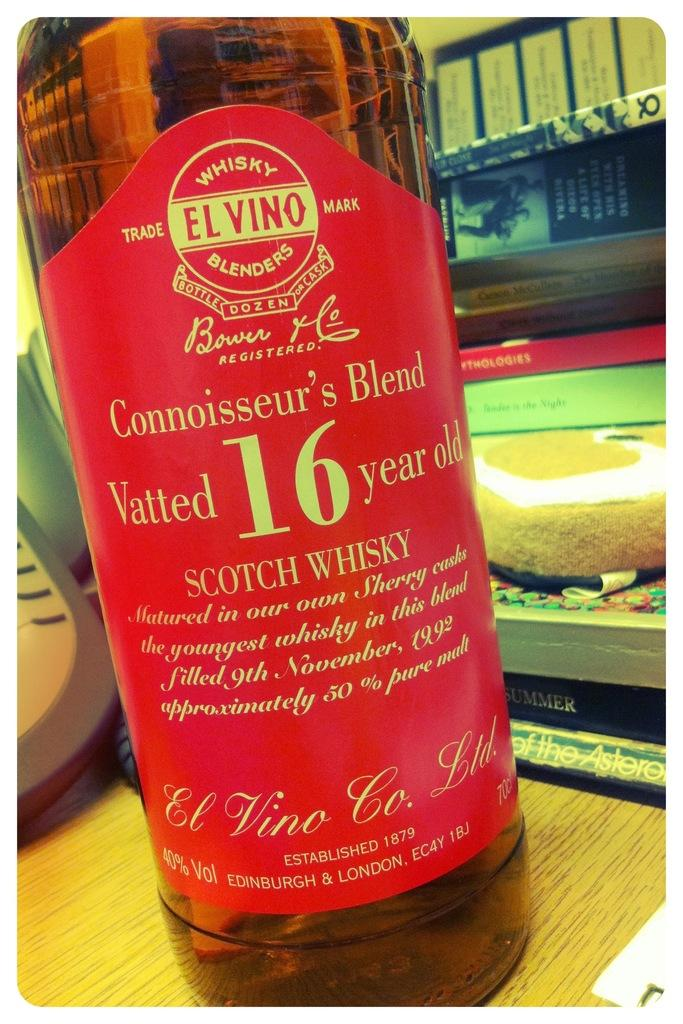<image>
Share a concise interpretation of the image provided. A close-up of a scotch whiskey with a red label 